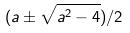<formula> <loc_0><loc_0><loc_500><loc_500>( a \pm \sqrt { a ^ { 2 } - 4 } ) / 2</formula> 